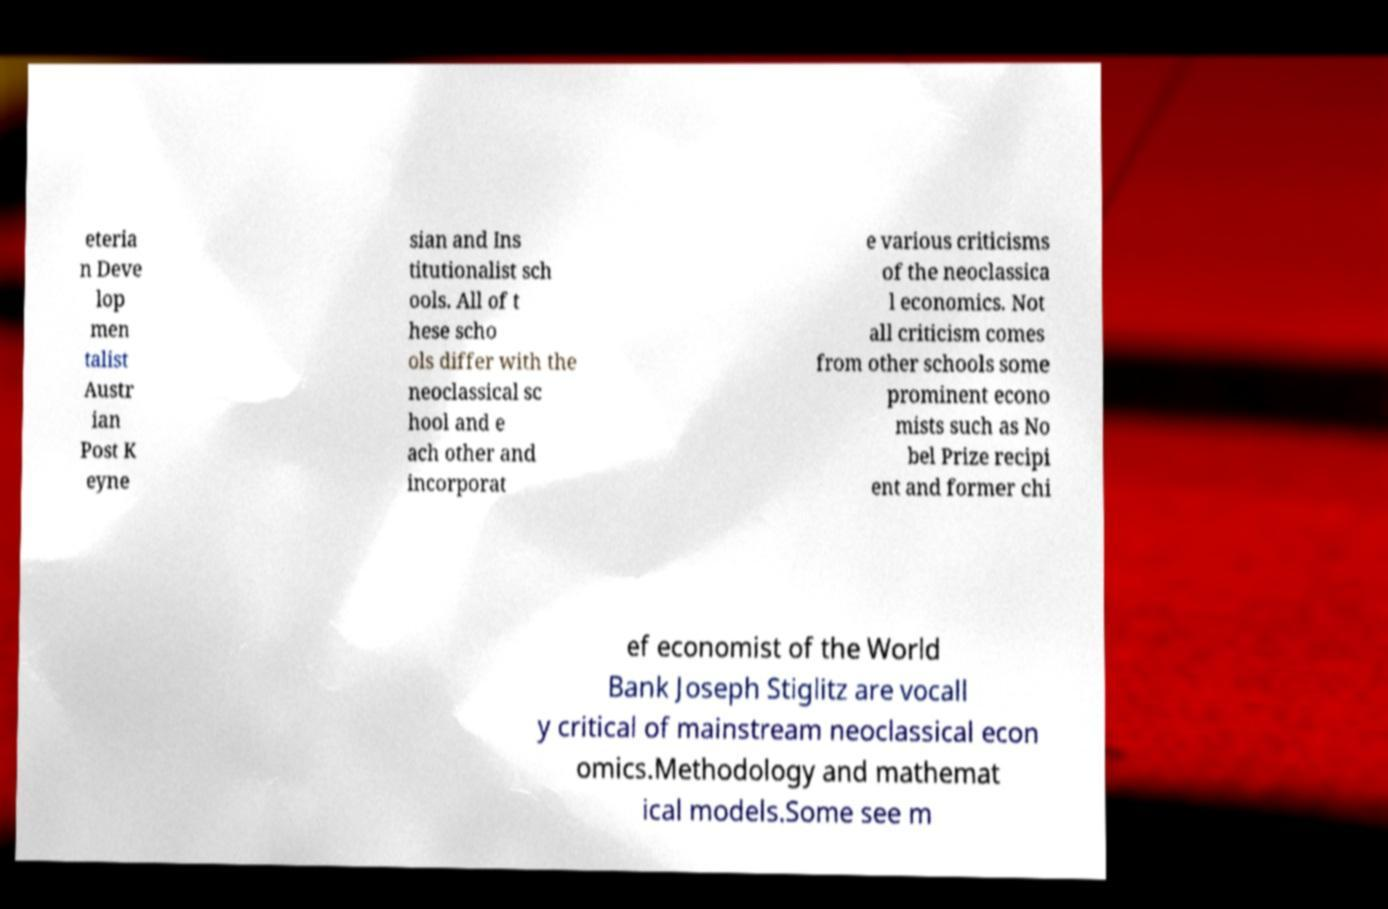Can you read and provide the text displayed in the image?This photo seems to have some interesting text. Can you extract and type it out for me? eteria n Deve lop men talist Austr ian Post K eyne sian and Ins titutionalist sch ools. All of t hese scho ols differ with the neoclassical sc hool and e ach other and incorporat e various criticisms of the neoclassica l economics. Not all criticism comes from other schools some prominent econo mists such as No bel Prize recipi ent and former chi ef economist of the World Bank Joseph Stiglitz are vocall y critical of mainstream neoclassical econ omics.Methodology and mathemat ical models.Some see m 